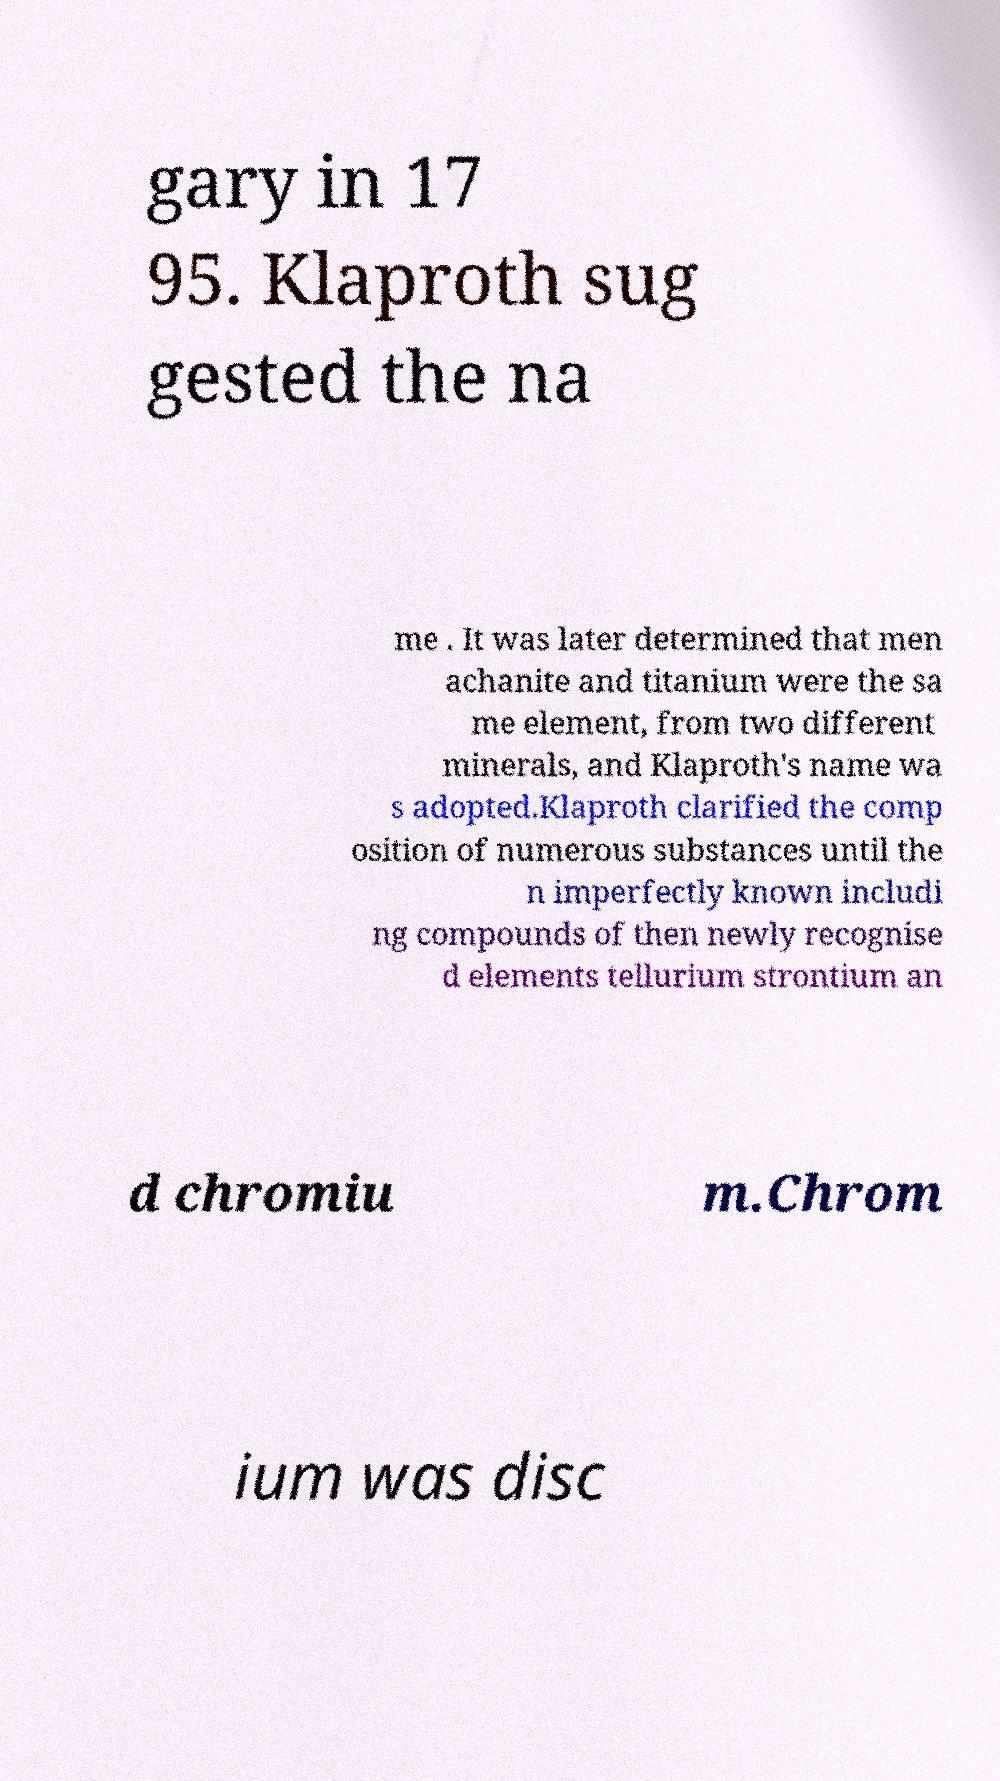Please identify and transcribe the text found in this image. gary in 17 95. Klaproth sug gested the na me . It was later determined that men achanite and titanium were the sa me element, from two different minerals, and Klaproth's name wa s adopted.Klaproth clarified the comp osition of numerous substances until the n imperfectly known includi ng compounds of then newly recognise d elements tellurium strontium an d chromiu m.Chrom ium was disc 